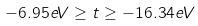<formula> <loc_0><loc_0><loc_500><loc_500>- 6 . 9 5 e V \geq t \geq - 1 6 . 3 4 e V</formula> 